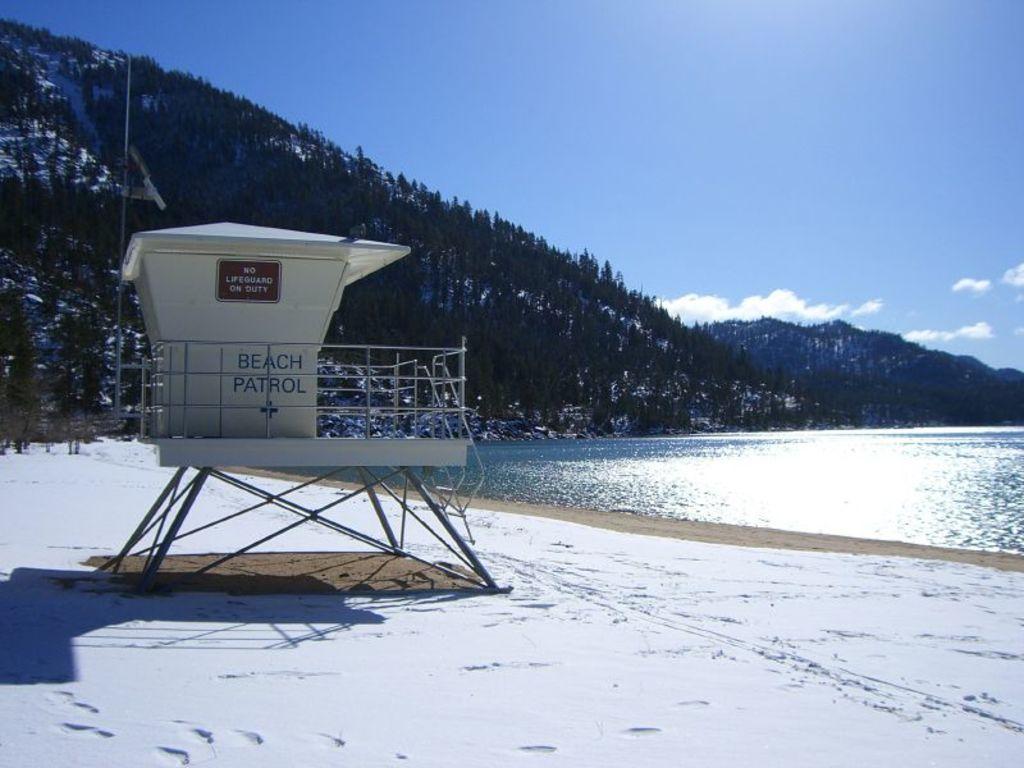How would you summarize this image in a sentence or two? This picture shows few trees and we see water and a beach patrol on the shore and we see a blue cloudy sky and snow on the ground. 